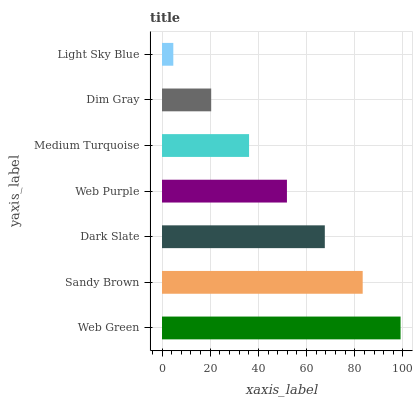Is Light Sky Blue the minimum?
Answer yes or no. Yes. Is Web Green the maximum?
Answer yes or no. Yes. Is Sandy Brown the minimum?
Answer yes or no. No. Is Sandy Brown the maximum?
Answer yes or no. No. Is Web Green greater than Sandy Brown?
Answer yes or no. Yes. Is Sandy Brown less than Web Green?
Answer yes or no. Yes. Is Sandy Brown greater than Web Green?
Answer yes or no. No. Is Web Green less than Sandy Brown?
Answer yes or no. No. Is Web Purple the high median?
Answer yes or no. Yes. Is Web Purple the low median?
Answer yes or no. Yes. Is Dark Slate the high median?
Answer yes or no. No. Is Light Sky Blue the low median?
Answer yes or no. No. 